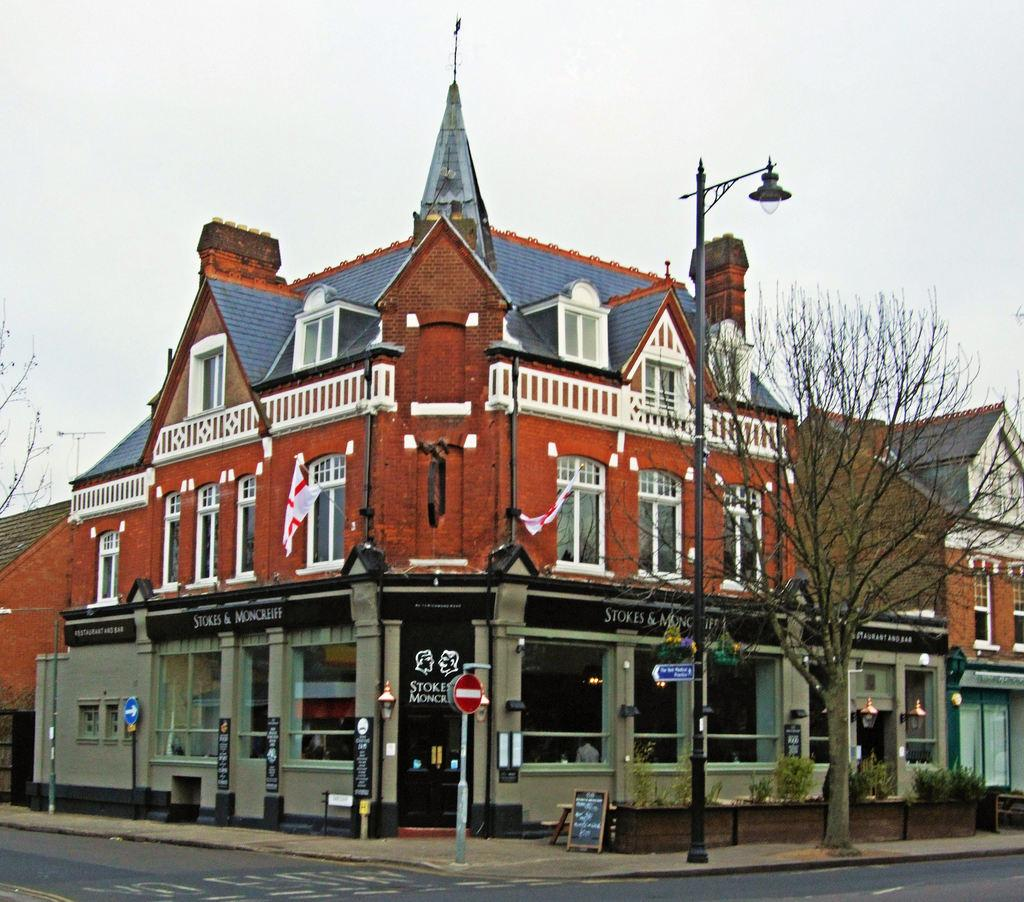What can be seen on the poles in the image? There are lights and boards on poles in the image. What is the condition of the tree in the image? The tree in the image is dried. Where is the board located in the image besides on the poles? There is a board on a surface in the image. What type of vegetation is present in the image? There are plants in the image. What type of man-made structure can be seen in the image? There is a building in the image. What is visible in the background of the image? The sky is visible in the background of the image. What type of pathway is present in the image? There is a road in the image. Can you see any rifles being used at the party in the image? There is no party or rifle present in the image. Is there steam coming out of the building in the image? There is no steam visible in the image. 